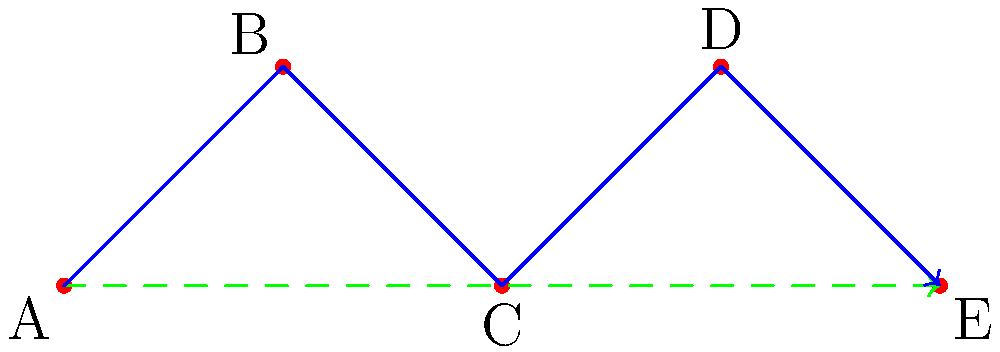In the network shown above, a classical routing protocol follows the path A-B-C-D-E (solid blue line), while a quantum routing protocol takes the path A-C-E (dashed green line). If the probability of successful transmission between any two directly connected nodes is 0.9 for both classical and quantum protocols, what is the ratio of the overall success probability of the quantum route to the classical route? To solve this problem, we need to calculate the success probabilities for both routes and then find their ratio:

1. Classical route (A-B-C-D-E):
   - This route has 4 hops.
   - Probability of success = $0.9^4 = 0.6561$

2. Quantum route (A-C-E):
   - This route has 2 hops.
   - Probability of success = $0.9^2 = 0.81$

3. Ratio of quantum to classical success probability:
   $\frac{\text{Quantum success probability}}{\text{Classical success probability}} = \frac{0.81}{0.6561}$

4. Simplify the ratio:
   $\frac{0.81}{0.6561} = \frac{81}{65.61} \approx 1.2345$

Therefore, the ratio of the overall success probability of the quantum route to the classical route is approximately 1.2345.
Answer: 1.2345 